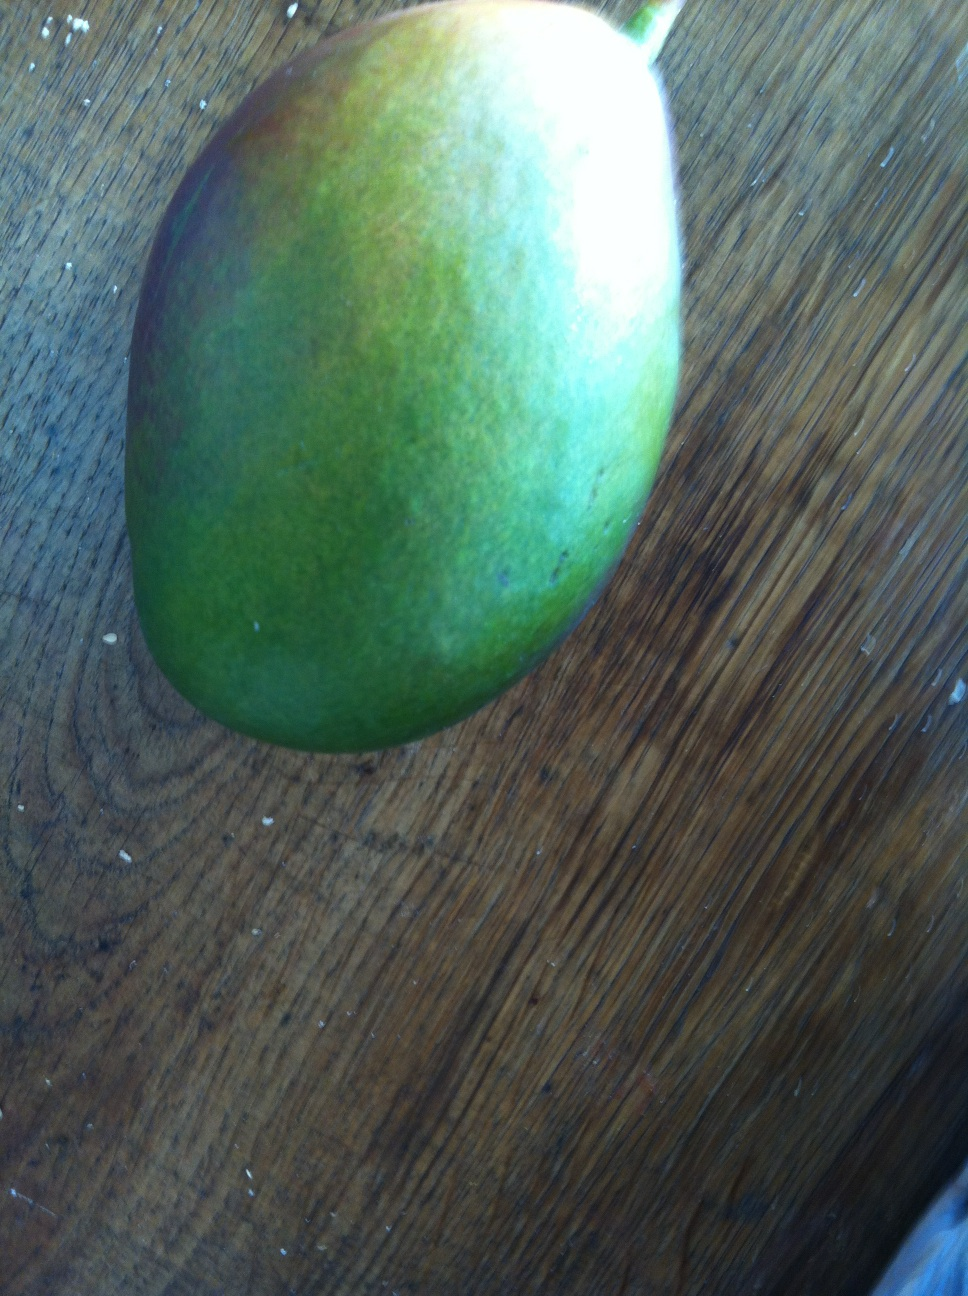Could you tell what kind of fruit this is? Because I think it's a mango but I'm not sure, it looks like an apple. The fruit in the image is indeed a mango. Mangoes can come in a variety of shapes and colors, including green, yellow, and red. This particular mango is likely in the earlier stages of ripeness, as indicated by its predominantly green coloration with some yellow tones. As it ripens further, you can expect the yellow areas to expand and the fruit to soften. While it might resemble an apple in shape, its smooth skin without the distinctive apple dimple around the stem is a clear indicator that it's a mango. 